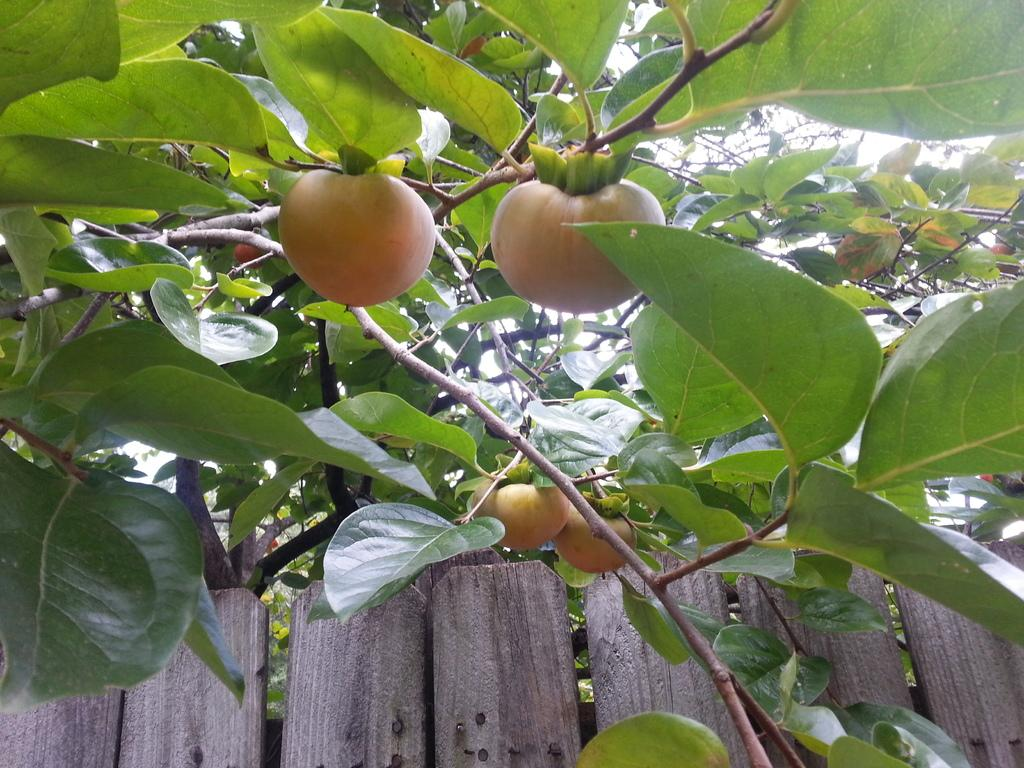What is located in the foreground of the image? There is a plant and fruits in the foreground of the image. What type of material is used for the boards at the bottom of the image? The boards at the bottom of the image are made of wood. What health benefits can be gained from the mark on the carpenter's hand in the image? There is no carpenter or mark on a hand present in the image. 